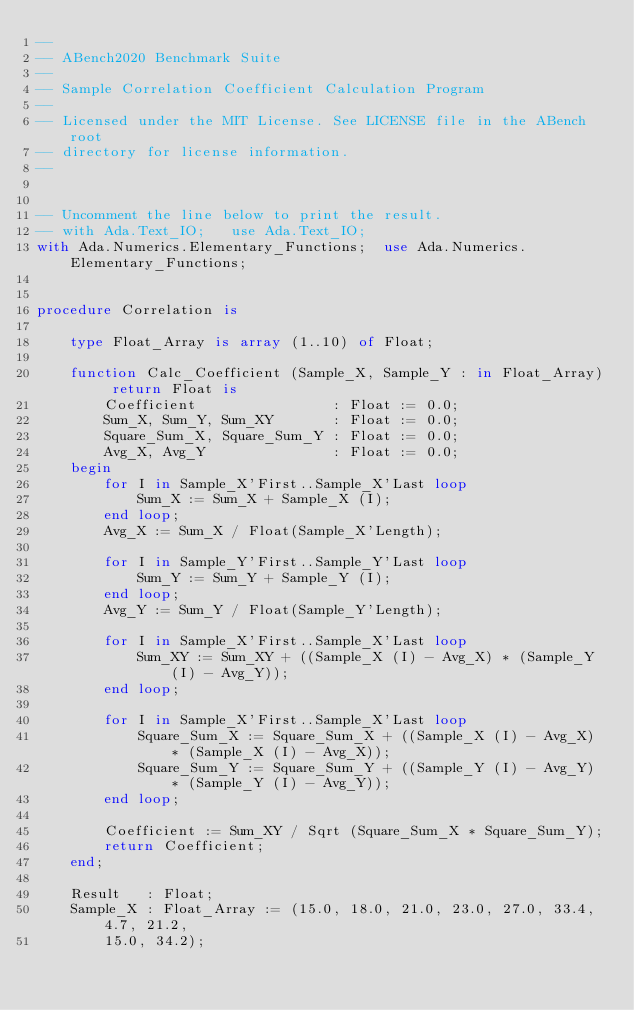<code> <loc_0><loc_0><loc_500><loc_500><_Ada_>--
-- ABench2020 Benchmark Suite
--
-- Sample Correlation Coefficient Calculation Program
--
-- Licensed under the MIT License. See LICENSE file in the ABench root 
-- directory for license information.
--


-- Uncomment the line below to print the result.
-- with Ada.Text_IO;   use Ada.Text_IO;
with Ada.Numerics.Elementary_Functions;  use Ada.Numerics.Elementary_Functions;


procedure Correlation is

    type Float_Array is array (1..10) of Float;

    function Calc_Coefficient (Sample_X, Sample_Y : in Float_Array) return Float is
        Coefficient                : Float := 0.0;
        Sum_X, Sum_Y, Sum_XY       : Float := 0.0;
        Square_Sum_X, Square_Sum_Y : Float := 0.0;
        Avg_X, Avg_Y               : Float := 0.0;
    begin
        for I in Sample_X'First..Sample_X'Last loop
            Sum_X := Sum_X + Sample_X (I);
        end loop;
        Avg_X := Sum_X / Float(Sample_X'Length);

        for I in Sample_Y'First..Sample_Y'Last loop
            Sum_Y := Sum_Y + Sample_Y (I);
        end loop;
        Avg_Y := Sum_Y / Float(Sample_Y'Length);

        for I in Sample_X'First..Sample_X'Last loop
            Sum_XY := Sum_XY + ((Sample_X (I) - Avg_X) * (Sample_Y (I) - Avg_Y));
        end loop;

        for I in Sample_X'First..Sample_X'Last loop
            Square_Sum_X := Square_Sum_X + ((Sample_X (I) - Avg_X) * (Sample_X (I) - Avg_X));
            Square_Sum_Y := Square_Sum_Y + ((Sample_Y (I) - Avg_Y) * (Sample_Y (I) - Avg_Y));
        end loop;

        Coefficient := Sum_XY / Sqrt (Square_Sum_X * Square_Sum_Y);
        return Coefficient;
    end;

    Result   : Float;
    Sample_X : Float_Array := (15.0, 18.0, 21.0, 23.0, 27.0, 33.4, 4.7, 21.2, 
        15.0, 34.2);</code> 